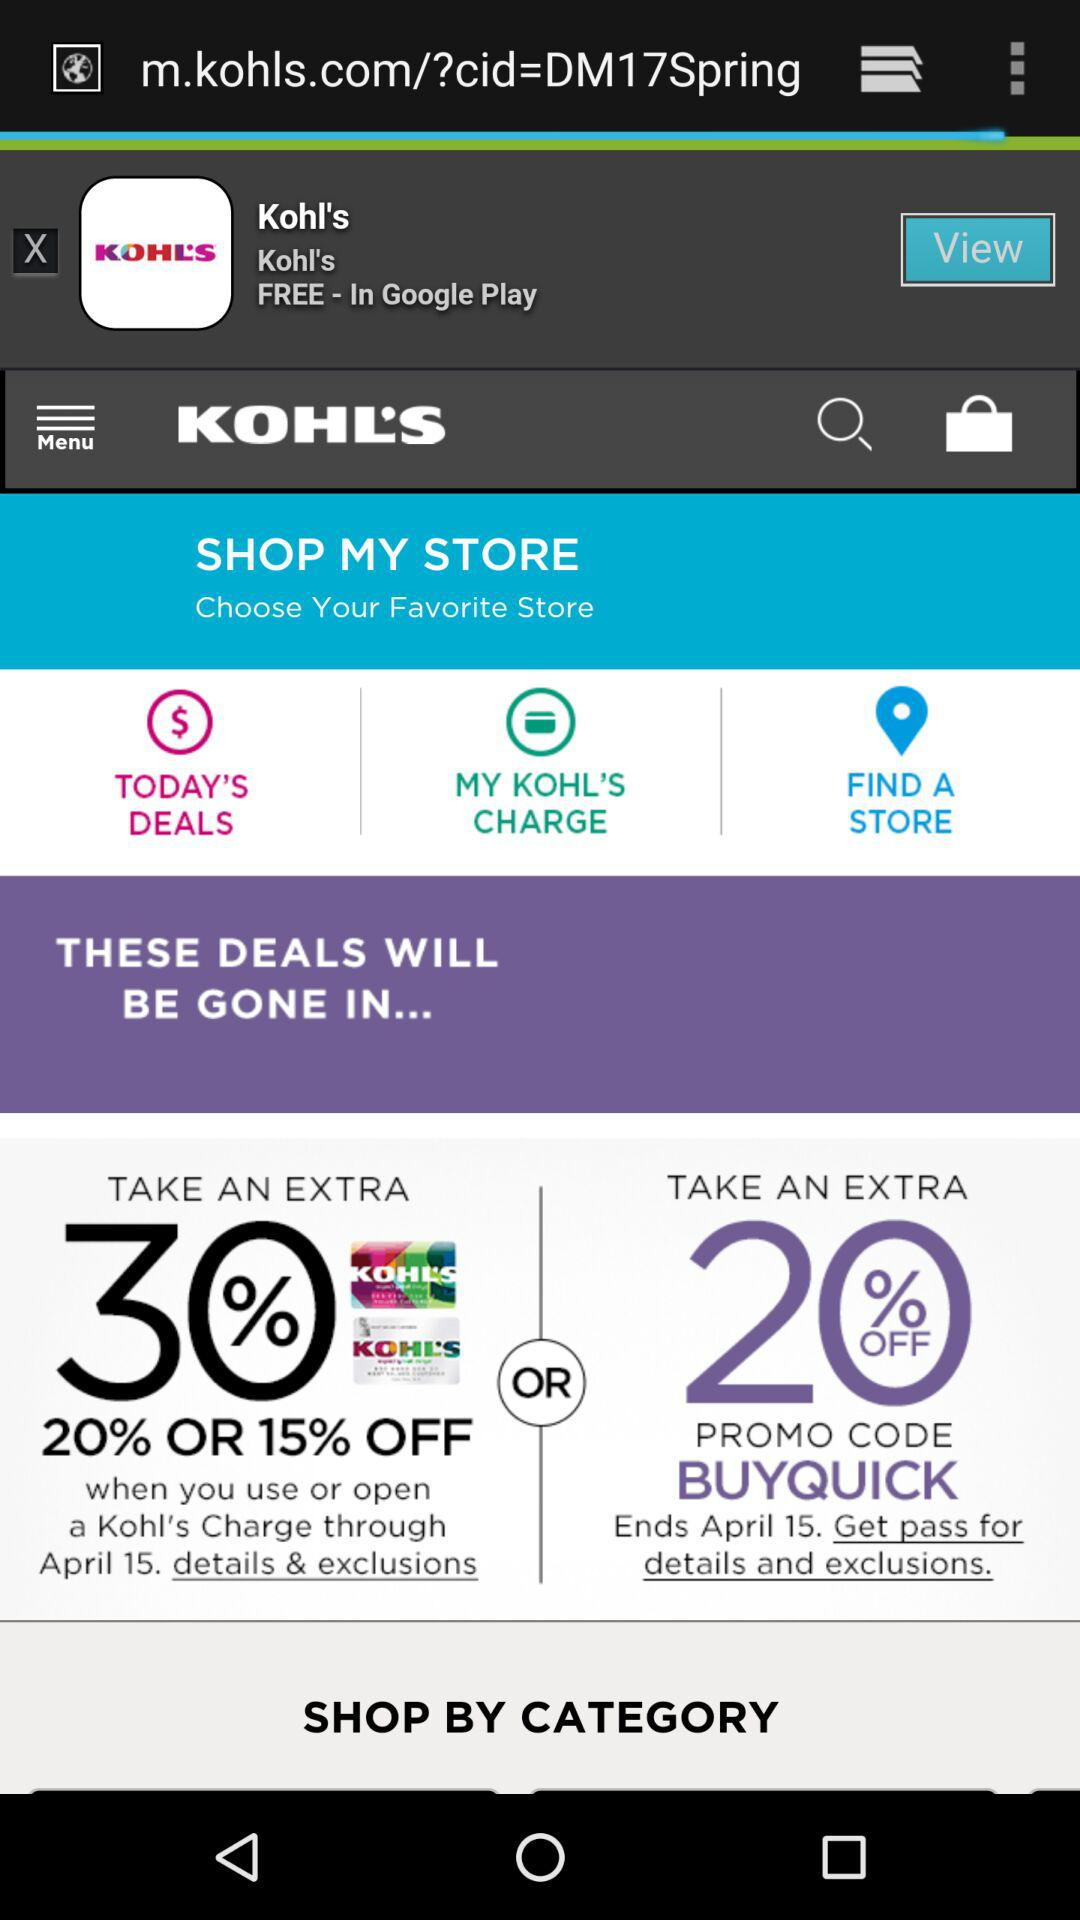How many items are offered in the "Take an extra 20% off" promotion?
Answer the question using a single word or phrase. 2 